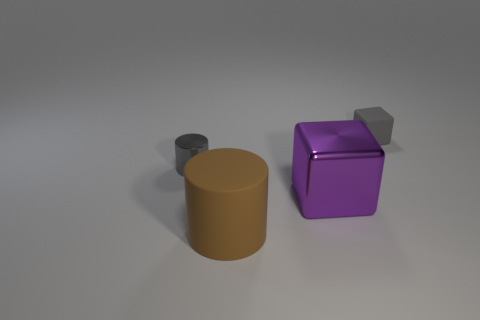Add 2 tiny shiny things. How many objects exist? 6 Add 4 gray things. How many gray things exist? 6 Subtract 0 brown cubes. How many objects are left? 4 Subtract 1 cylinders. How many cylinders are left? 1 Subtract all purple cylinders. Subtract all red cubes. How many cylinders are left? 2 Subtract all green spheres. How many purple cubes are left? 1 Subtract all gray rubber objects. Subtract all big rubber objects. How many objects are left? 2 Add 4 small cylinders. How many small cylinders are left? 5 